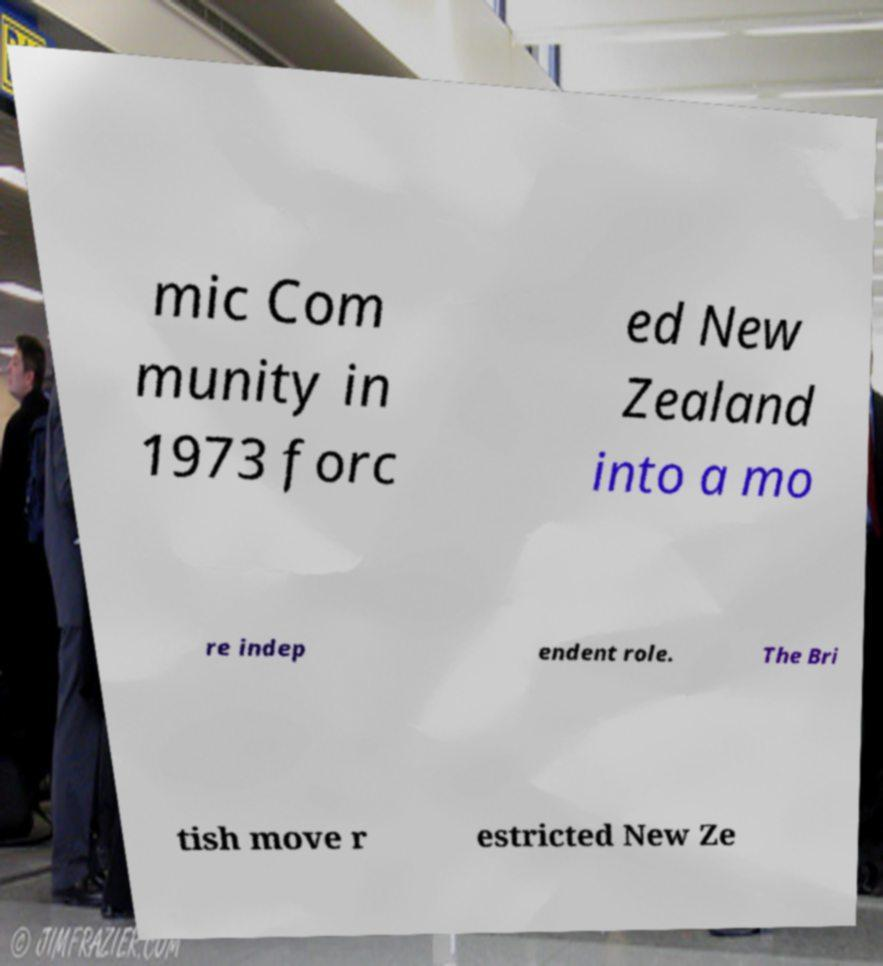Please identify and transcribe the text found in this image. mic Com munity in 1973 forc ed New Zealand into a mo re indep endent role. The Bri tish move r estricted New Ze 